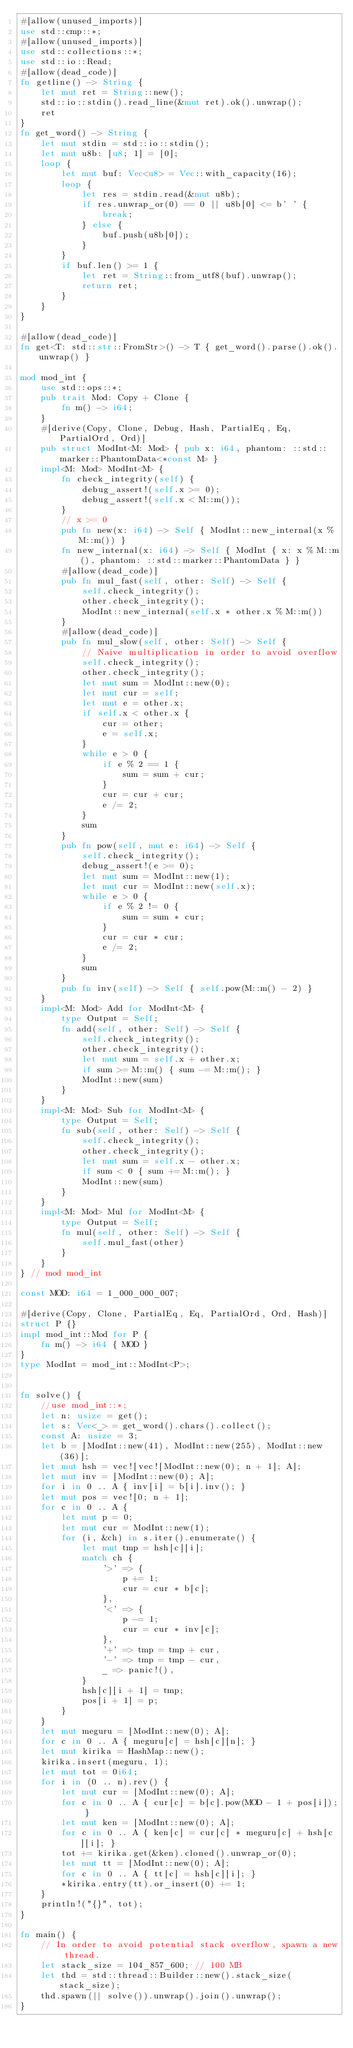Convert code to text. <code><loc_0><loc_0><loc_500><loc_500><_Rust_>#[allow(unused_imports)]
use std::cmp::*;
#[allow(unused_imports)]
use std::collections::*;
use std::io::Read;
#[allow(dead_code)]
fn getline() -> String {
    let mut ret = String::new();
    std::io::stdin().read_line(&mut ret).ok().unwrap();
    ret
}
fn get_word() -> String {
    let mut stdin = std::io::stdin();
    let mut u8b: [u8; 1] = [0];
    loop {
        let mut buf: Vec<u8> = Vec::with_capacity(16);
        loop {
            let res = stdin.read(&mut u8b);
            if res.unwrap_or(0) == 0 || u8b[0] <= b' ' {
                break;
            } else {
                buf.push(u8b[0]);
            }
        }
        if buf.len() >= 1 {
            let ret = String::from_utf8(buf).unwrap();
            return ret;
        }
    }
}

#[allow(dead_code)]
fn get<T: std::str::FromStr>() -> T { get_word().parse().ok().unwrap() }

mod mod_int {
    use std::ops::*;
    pub trait Mod: Copy + Clone {
        fn m() -> i64;
    }
    #[derive(Copy, Clone, Debug, Hash, PartialEq, Eq, PartialOrd, Ord)]
    pub struct ModInt<M: Mod> { pub x: i64, phantom: ::std::marker::PhantomData<*const M> }
    impl<M: Mod> ModInt<M> {
        fn check_integrity(self) {
            debug_assert!(self.x >= 0);
            debug_assert!(self.x < M::m());
        }
        // x >= 0
        pub fn new(x: i64) -> Self { ModInt::new_internal(x % M::m()) }
        fn new_internal(x: i64) -> Self { ModInt { x: x % M::m(), phantom: ::std::marker::PhantomData } }
        #[allow(dead_code)]
        pub fn mul_fast(self, other: Self) -> Self {
            self.check_integrity();
            other.check_integrity();
            ModInt::new_internal(self.x * other.x % M::m())
        }
        #[allow(dead_code)]
        pub fn mul_slow(self, other: Self) -> Self {
            // Naive multiplication in order to avoid overflow
            self.check_integrity();
            other.check_integrity();
            let mut sum = ModInt::new(0);
            let mut cur = self;
            let mut e = other.x;
            if self.x < other.x {
                cur = other;
                e = self.x;
            }
            while e > 0 {
                if e % 2 == 1 {
                    sum = sum + cur;
                }
                cur = cur + cur;
                e /= 2;
            }
            sum
        }
        pub fn pow(self, mut e: i64) -> Self {
            self.check_integrity();
            debug_assert!(e >= 0);
            let mut sum = ModInt::new(1);
            let mut cur = ModInt::new(self.x);
            while e > 0 {
                if e % 2 != 0 {
                    sum = sum * cur;
                }
                cur = cur * cur;
                e /= 2;
            }
            sum
        }
        pub fn inv(self) -> Self { self.pow(M::m() - 2) }
    }
    impl<M: Mod> Add for ModInt<M> {
        type Output = Self;
        fn add(self, other: Self) -> Self {
            self.check_integrity();
            other.check_integrity();
            let mut sum = self.x + other.x;
            if sum >= M::m() { sum -= M::m(); }
            ModInt::new(sum)
        }
    }
    impl<M: Mod> Sub for ModInt<M> {
        type Output = Self;
        fn sub(self, other: Self) -> Self {
            self.check_integrity();
            other.check_integrity();
            let mut sum = self.x - other.x;
            if sum < 0 { sum += M::m(); }
            ModInt::new(sum)
        }
    }
    impl<M: Mod> Mul for ModInt<M> {
        type Output = Self;
        fn mul(self, other: Self) -> Self {
            self.mul_fast(other)
        }
    }
} // mod mod_int

const MOD: i64 = 1_000_000_007;

#[derive(Copy, Clone, PartialEq, Eq, PartialOrd, Ord, Hash)]
struct P {}
impl mod_int::Mod for P {
    fn m() -> i64 { MOD }
}
type ModInt = mod_int::ModInt<P>;


fn solve() {
    //use mod_int::*;
    let n: usize = get();
    let s: Vec<_> = get_word().chars().collect();
    const A: usize = 3;
    let b = [ModInt::new(41), ModInt::new(255), ModInt::new(36)];
    let mut hsh = vec![vec![ModInt::new(0); n + 1]; A];
    let mut inv = [ModInt::new(0); A];
    for i in 0 .. A { inv[i] = b[i].inv(); }
    let mut pos = vec![0; n + 1];
    for c in 0 .. A {
        let mut p = 0;
        let mut cur = ModInt::new(1);
        for (i, &ch) in s.iter().enumerate() {
            let mut tmp = hsh[c][i];
            match ch {
                '>' => {
                    p += 1;
                    cur = cur * b[c];
                },
                '<' => {
                    p -= 1;
                    cur = cur * inv[c];
                },
                '+' => tmp = tmp + cur,
                '-' => tmp = tmp - cur,
                _ => panic!(),
            }
            hsh[c][i + 1] = tmp;
            pos[i + 1] = p;
        }
    }
    let mut meguru = [ModInt::new(0); A];
    for c in 0 .. A { meguru[c] = hsh[c][n]; }
    let mut kirika = HashMap::new();
    kirika.insert(meguru, 1);
    let mut tot = 0i64;
    for i in (0 .. n).rev() {
        let mut cur = [ModInt::new(0); A];
        for c in 0 .. A { cur[c] = b[c].pow(MOD - 1 + pos[i]); }
        let mut ken = [ModInt::new(0); A];
        for c in 0 .. A { ken[c] = cur[c] * meguru[c] + hsh[c][i]; }
        tot += kirika.get(&ken).cloned().unwrap_or(0);
        let mut tt = [ModInt::new(0); A];
        for c in 0 .. A { tt[c] = hsh[c][i]; }
        *kirika.entry(tt).or_insert(0) += 1;
    }
    println!("{}", tot);
}

fn main() {
    // In order to avoid potential stack overflow, spawn a new thread.
    let stack_size = 104_857_600; // 100 MB
    let thd = std::thread::Builder::new().stack_size(stack_size);
    thd.spawn(|| solve()).unwrap().join().unwrap();
}
</code> 